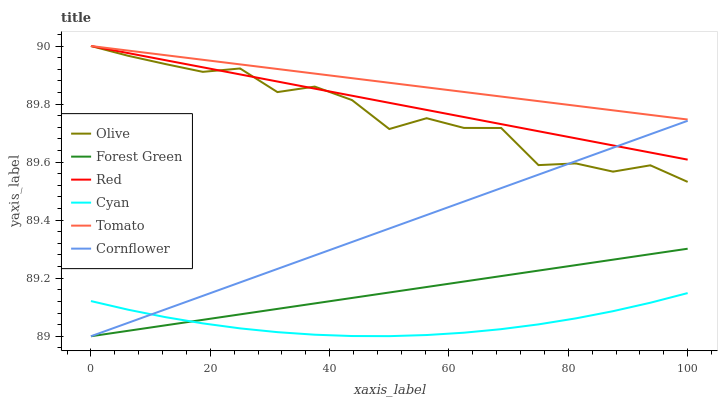Does Cyan have the minimum area under the curve?
Answer yes or no. Yes. Does Tomato have the maximum area under the curve?
Answer yes or no. Yes. Does Cornflower have the minimum area under the curve?
Answer yes or no. No. Does Cornflower have the maximum area under the curve?
Answer yes or no. No. Is Red the smoothest?
Answer yes or no. Yes. Is Olive the roughest?
Answer yes or no. Yes. Is Cornflower the smoothest?
Answer yes or no. No. Is Cornflower the roughest?
Answer yes or no. No. Does Olive have the lowest value?
Answer yes or no. No. Does Red have the highest value?
Answer yes or no. Yes. Does Cornflower have the highest value?
Answer yes or no. No. Is Cyan less than Red?
Answer yes or no. Yes. Is Tomato greater than Cornflower?
Answer yes or no. Yes. Does Red intersect Olive?
Answer yes or no. Yes. Is Red less than Olive?
Answer yes or no. No. Is Red greater than Olive?
Answer yes or no. No. Does Cyan intersect Red?
Answer yes or no. No. 